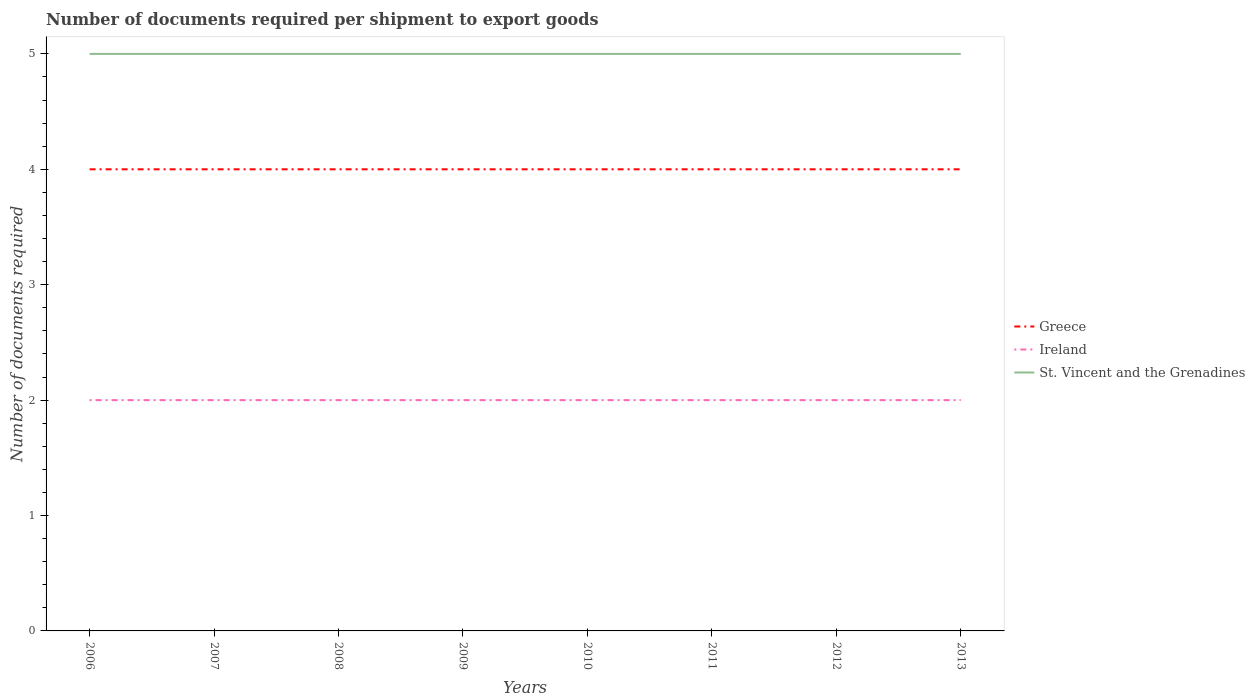Is the number of lines equal to the number of legend labels?
Offer a terse response. Yes. Across all years, what is the maximum number of documents required per shipment to export goods in Ireland?
Offer a terse response. 2. In which year was the number of documents required per shipment to export goods in St. Vincent and the Grenadines maximum?
Keep it short and to the point. 2006. What is the total number of documents required per shipment to export goods in St. Vincent and the Grenadines in the graph?
Ensure brevity in your answer.  0. What is the difference between the highest and the second highest number of documents required per shipment to export goods in Ireland?
Give a very brief answer. 0. Is the number of documents required per shipment to export goods in Greece strictly greater than the number of documents required per shipment to export goods in Ireland over the years?
Give a very brief answer. No. How many lines are there?
Your response must be concise. 3. How many years are there in the graph?
Give a very brief answer. 8. Where does the legend appear in the graph?
Your answer should be very brief. Center right. How many legend labels are there?
Your answer should be very brief. 3. What is the title of the graph?
Give a very brief answer. Number of documents required per shipment to export goods. Does "Iceland" appear as one of the legend labels in the graph?
Provide a succinct answer. No. What is the label or title of the X-axis?
Provide a succinct answer. Years. What is the label or title of the Y-axis?
Keep it short and to the point. Number of documents required. What is the Number of documents required in Greece in 2007?
Your answer should be compact. 4. What is the Number of documents required in St. Vincent and the Grenadines in 2007?
Your response must be concise. 5. What is the Number of documents required in Greece in 2008?
Keep it short and to the point. 4. What is the Number of documents required of Ireland in 2009?
Offer a very short reply. 2. What is the Number of documents required of St. Vincent and the Grenadines in 2009?
Ensure brevity in your answer.  5. What is the Number of documents required in Greece in 2010?
Ensure brevity in your answer.  4. What is the Number of documents required in Ireland in 2010?
Offer a terse response. 2. What is the Number of documents required in St. Vincent and the Grenadines in 2010?
Make the answer very short. 5. What is the Number of documents required of Ireland in 2011?
Make the answer very short. 2. What is the Number of documents required of Greece in 2012?
Provide a short and direct response. 4. What is the Number of documents required of Greece in 2013?
Provide a short and direct response. 4. Across all years, what is the maximum Number of documents required in Greece?
Offer a terse response. 4. Across all years, what is the maximum Number of documents required of Ireland?
Provide a short and direct response. 2. What is the total Number of documents required of Greece in the graph?
Provide a short and direct response. 32. What is the difference between the Number of documents required of Greece in 2006 and that in 2007?
Offer a terse response. 0. What is the difference between the Number of documents required in Ireland in 2006 and that in 2007?
Your response must be concise. 0. What is the difference between the Number of documents required in St. Vincent and the Grenadines in 2006 and that in 2007?
Ensure brevity in your answer.  0. What is the difference between the Number of documents required in Ireland in 2006 and that in 2008?
Your answer should be very brief. 0. What is the difference between the Number of documents required in St. Vincent and the Grenadines in 2006 and that in 2008?
Provide a short and direct response. 0. What is the difference between the Number of documents required in Greece in 2006 and that in 2010?
Your answer should be compact. 0. What is the difference between the Number of documents required of Ireland in 2006 and that in 2010?
Give a very brief answer. 0. What is the difference between the Number of documents required of Ireland in 2006 and that in 2013?
Ensure brevity in your answer.  0. What is the difference between the Number of documents required in St. Vincent and the Grenadines in 2006 and that in 2013?
Make the answer very short. 0. What is the difference between the Number of documents required of Greece in 2007 and that in 2008?
Your answer should be compact. 0. What is the difference between the Number of documents required of St. Vincent and the Grenadines in 2007 and that in 2008?
Provide a short and direct response. 0. What is the difference between the Number of documents required in Greece in 2007 and that in 2009?
Your answer should be compact. 0. What is the difference between the Number of documents required of St. Vincent and the Grenadines in 2007 and that in 2009?
Ensure brevity in your answer.  0. What is the difference between the Number of documents required of Greece in 2007 and that in 2010?
Make the answer very short. 0. What is the difference between the Number of documents required of St. Vincent and the Grenadines in 2007 and that in 2010?
Provide a succinct answer. 0. What is the difference between the Number of documents required in Ireland in 2007 and that in 2011?
Make the answer very short. 0. What is the difference between the Number of documents required in St. Vincent and the Grenadines in 2007 and that in 2012?
Keep it short and to the point. 0. What is the difference between the Number of documents required in Greece in 2007 and that in 2013?
Keep it short and to the point. 0. What is the difference between the Number of documents required of Ireland in 2007 and that in 2013?
Provide a succinct answer. 0. What is the difference between the Number of documents required of Greece in 2008 and that in 2009?
Offer a very short reply. 0. What is the difference between the Number of documents required in Ireland in 2008 and that in 2009?
Provide a short and direct response. 0. What is the difference between the Number of documents required of Greece in 2008 and that in 2010?
Offer a terse response. 0. What is the difference between the Number of documents required of Ireland in 2008 and that in 2010?
Keep it short and to the point. 0. What is the difference between the Number of documents required in Greece in 2008 and that in 2011?
Offer a very short reply. 0. What is the difference between the Number of documents required of Ireland in 2008 and that in 2011?
Give a very brief answer. 0. What is the difference between the Number of documents required of St. Vincent and the Grenadines in 2008 and that in 2011?
Provide a short and direct response. 0. What is the difference between the Number of documents required of Ireland in 2008 and that in 2012?
Your answer should be compact. 0. What is the difference between the Number of documents required in Greece in 2008 and that in 2013?
Your answer should be compact. 0. What is the difference between the Number of documents required of Ireland in 2008 and that in 2013?
Make the answer very short. 0. What is the difference between the Number of documents required of St. Vincent and the Grenadines in 2009 and that in 2010?
Give a very brief answer. 0. What is the difference between the Number of documents required of Ireland in 2009 and that in 2012?
Your answer should be compact. 0. What is the difference between the Number of documents required in St. Vincent and the Grenadines in 2009 and that in 2012?
Provide a short and direct response. 0. What is the difference between the Number of documents required of St. Vincent and the Grenadines in 2009 and that in 2013?
Provide a succinct answer. 0. What is the difference between the Number of documents required of St. Vincent and the Grenadines in 2010 and that in 2011?
Offer a very short reply. 0. What is the difference between the Number of documents required of Greece in 2010 and that in 2012?
Keep it short and to the point. 0. What is the difference between the Number of documents required of Ireland in 2010 and that in 2012?
Make the answer very short. 0. What is the difference between the Number of documents required in Greece in 2010 and that in 2013?
Offer a terse response. 0. What is the difference between the Number of documents required of Ireland in 2010 and that in 2013?
Ensure brevity in your answer.  0. What is the difference between the Number of documents required in St. Vincent and the Grenadines in 2010 and that in 2013?
Make the answer very short. 0. What is the difference between the Number of documents required of Ireland in 2011 and that in 2012?
Your answer should be compact. 0. What is the difference between the Number of documents required of Greece in 2011 and that in 2013?
Provide a short and direct response. 0. What is the difference between the Number of documents required in Ireland in 2012 and that in 2013?
Provide a succinct answer. 0. What is the difference between the Number of documents required in Greece in 2006 and the Number of documents required in Ireland in 2007?
Your answer should be compact. 2. What is the difference between the Number of documents required in Greece in 2006 and the Number of documents required in St. Vincent and the Grenadines in 2007?
Make the answer very short. -1. What is the difference between the Number of documents required of Ireland in 2006 and the Number of documents required of St. Vincent and the Grenadines in 2007?
Give a very brief answer. -3. What is the difference between the Number of documents required in Greece in 2006 and the Number of documents required in St. Vincent and the Grenadines in 2008?
Keep it short and to the point. -1. What is the difference between the Number of documents required of Greece in 2006 and the Number of documents required of Ireland in 2009?
Provide a succinct answer. 2. What is the difference between the Number of documents required in Greece in 2006 and the Number of documents required in St. Vincent and the Grenadines in 2009?
Give a very brief answer. -1. What is the difference between the Number of documents required of Ireland in 2006 and the Number of documents required of St. Vincent and the Grenadines in 2009?
Ensure brevity in your answer.  -3. What is the difference between the Number of documents required in Greece in 2006 and the Number of documents required in Ireland in 2010?
Your answer should be very brief. 2. What is the difference between the Number of documents required of Greece in 2006 and the Number of documents required of St. Vincent and the Grenadines in 2010?
Your response must be concise. -1. What is the difference between the Number of documents required in Greece in 2006 and the Number of documents required in Ireland in 2011?
Make the answer very short. 2. What is the difference between the Number of documents required of Greece in 2006 and the Number of documents required of St. Vincent and the Grenadines in 2011?
Your answer should be very brief. -1. What is the difference between the Number of documents required in Greece in 2006 and the Number of documents required in Ireland in 2012?
Provide a succinct answer. 2. What is the difference between the Number of documents required of Greece in 2006 and the Number of documents required of St. Vincent and the Grenadines in 2012?
Offer a very short reply. -1. What is the difference between the Number of documents required of Ireland in 2006 and the Number of documents required of St. Vincent and the Grenadines in 2012?
Offer a terse response. -3. What is the difference between the Number of documents required in Greece in 2006 and the Number of documents required in Ireland in 2013?
Provide a succinct answer. 2. What is the difference between the Number of documents required of Ireland in 2007 and the Number of documents required of St. Vincent and the Grenadines in 2008?
Your response must be concise. -3. What is the difference between the Number of documents required in Greece in 2007 and the Number of documents required in Ireland in 2010?
Offer a terse response. 2. What is the difference between the Number of documents required of Ireland in 2007 and the Number of documents required of St. Vincent and the Grenadines in 2010?
Your answer should be very brief. -3. What is the difference between the Number of documents required of Greece in 2007 and the Number of documents required of Ireland in 2011?
Keep it short and to the point. 2. What is the difference between the Number of documents required of Greece in 2007 and the Number of documents required of St. Vincent and the Grenadines in 2011?
Provide a short and direct response. -1. What is the difference between the Number of documents required of Greece in 2007 and the Number of documents required of St. Vincent and the Grenadines in 2012?
Make the answer very short. -1. What is the difference between the Number of documents required in Ireland in 2007 and the Number of documents required in St. Vincent and the Grenadines in 2012?
Your answer should be very brief. -3. What is the difference between the Number of documents required in Ireland in 2007 and the Number of documents required in St. Vincent and the Grenadines in 2013?
Your answer should be compact. -3. What is the difference between the Number of documents required of Greece in 2008 and the Number of documents required of Ireland in 2009?
Provide a short and direct response. 2. What is the difference between the Number of documents required in Greece in 2008 and the Number of documents required in St. Vincent and the Grenadines in 2010?
Your answer should be very brief. -1. What is the difference between the Number of documents required of Ireland in 2008 and the Number of documents required of St. Vincent and the Grenadines in 2010?
Your answer should be very brief. -3. What is the difference between the Number of documents required of Greece in 2008 and the Number of documents required of Ireland in 2011?
Your answer should be very brief. 2. What is the difference between the Number of documents required in Ireland in 2008 and the Number of documents required in St. Vincent and the Grenadines in 2011?
Ensure brevity in your answer.  -3. What is the difference between the Number of documents required in Ireland in 2008 and the Number of documents required in St. Vincent and the Grenadines in 2012?
Your answer should be compact. -3. What is the difference between the Number of documents required of Greece in 2008 and the Number of documents required of St. Vincent and the Grenadines in 2013?
Keep it short and to the point. -1. What is the difference between the Number of documents required of Greece in 2009 and the Number of documents required of St. Vincent and the Grenadines in 2010?
Your answer should be very brief. -1. What is the difference between the Number of documents required of Ireland in 2009 and the Number of documents required of St. Vincent and the Grenadines in 2010?
Provide a short and direct response. -3. What is the difference between the Number of documents required in Ireland in 2009 and the Number of documents required in St. Vincent and the Grenadines in 2012?
Ensure brevity in your answer.  -3. What is the difference between the Number of documents required in Greece in 2009 and the Number of documents required in Ireland in 2013?
Your response must be concise. 2. What is the difference between the Number of documents required in Greece in 2009 and the Number of documents required in St. Vincent and the Grenadines in 2013?
Make the answer very short. -1. What is the difference between the Number of documents required in Ireland in 2009 and the Number of documents required in St. Vincent and the Grenadines in 2013?
Offer a terse response. -3. What is the difference between the Number of documents required of Greece in 2010 and the Number of documents required of Ireland in 2011?
Provide a succinct answer. 2. What is the difference between the Number of documents required of Greece in 2010 and the Number of documents required of St. Vincent and the Grenadines in 2011?
Provide a short and direct response. -1. What is the difference between the Number of documents required of Greece in 2010 and the Number of documents required of Ireland in 2012?
Ensure brevity in your answer.  2. What is the difference between the Number of documents required of Greece in 2010 and the Number of documents required of St. Vincent and the Grenadines in 2012?
Provide a succinct answer. -1. What is the difference between the Number of documents required in Ireland in 2010 and the Number of documents required in St. Vincent and the Grenadines in 2012?
Your answer should be very brief. -3. What is the difference between the Number of documents required in Greece in 2010 and the Number of documents required in St. Vincent and the Grenadines in 2013?
Your answer should be compact. -1. What is the difference between the Number of documents required of Ireland in 2010 and the Number of documents required of St. Vincent and the Grenadines in 2013?
Ensure brevity in your answer.  -3. What is the difference between the Number of documents required of Greece in 2011 and the Number of documents required of Ireland in 2012?
Your response must be concise. 2. What is the difference between the Number of documents required of Greece in 2011 and the Number of documents required of St. Vincent and the Grenadines in 2012?
Your answer should be compact. -1. What is the difference between the Number of documents required of Ireland in 2011 and the Number of documents required of St. Vincent and the Grenadines in 2013?
Provide a succinct answer. -3. What is the difference between the Number of documents required of Greece in 2012 and the Number of documents required of St. Vincent and the Grenadines in 2013?
Offer a very short reply. -1. What is the difference between the Number of documents required in Ireland in 2012 and the Number of documents required in St. Vincent and the Grenadines in 2013?
Make the answer very short. -3. What is the average Number of documents required of Ireland per year?
Your answer should be very brief. 2. What is the average Number of documents required in St. Vincent and the Grenadines per year?
Your answer should be very brief. 5. In the year 2006, what is the difference between the Number of documents required of Greece and Number of documents required of Ireland?
Your answer should be very brief. 2. In the year 2006, what is the difference between the Number of documents required of Greece and Number of documents required of St. Vincent and the Grenadines?
Give a very brief answer. -1. In the year 2008, what is the difference between the Number of documents required in Greece and Number of documents required in St. Vincent and the Grenadines?
Your answer should be very brief. -1. In the year 2009, what is the difference between the Number of documents required in Ireland and Number of documents required in St. Vincent and the Grenadines?
Make the answer very short. -3. In the year 2010, what is the difference between the Number of documents required of Greece and Number of documents required of Ireland?
Keep it short and to the point. 2. In the year 2010, what is the difference between the Number of documents required in Ireland and Number of documents required in St. Vincent and the Grenadines?
Provide a succinct answer. -3. In the year 2011, what is the difference between the Number of documents required in Greece and Number of documents required in Ireland?
Provide a short and direct response. 2. In the year 2012, what is the difference between the Number of documents required of Ireland and Number of documents required of St. Vincent and the Grenadines?
Offer a terse response. -3. In the year 2013, what is the difference between the Number of documents required in Greece and Number of documents required in Ireland?
Your answer should be very brief. 2. In the year 2013, what is the difference between the Number of documents required in Ireland and Number of documents required in St. Vincent and the Grenadines?
Make the answer very short. -3. What is the ratio of the Number of documents required in Ireland in 2006 to that in 2007?
Provide a succinct answer. 1. What is the ratio of the Number of documents required of St. Vincent and the Grenadines in 2006 to that in 2007?
Make the answer very short. 1. What is the ratio of the Number of documents required in Greece in 2006 to that in 2009?
Keep it short and to the point. 1. What is the ratio of the Number of documents required in Ireland in 2006 to that in 2009?
Your answer should be compact. 1. What is the ratio of the Number of documents required of St. Vincent and the Grenadines in 2006 to that in 2009?
Your answer should be compact. 1. What is the ratio of the Number of documents required in Greece in 2006 to that in 2010?
Your answer should be very brief. 1. What is the ratio of the Number of documents required of St. Vincent and the Grenadines in 2006 to that in 2010?
Offer a very short reply. 1. What is the ratio of the Number of documents required of Ireland in 2006 to that in 2011?
Offer a terse response. 1. What is the ratio of the Number of documents required in Greece in 2006 to that in 2012?
Provide a short and direct response. 1. What is the ratio of the Number of documents required in St. Vincent and the Grenadines in 2006 to that in 2012?
Offer a terse response. 1. What is the ratio of the Number of documents required of Greece in 2007 to that in 2008?
Provide a succinct answer. 1. What is the ratio of the Number of documents required of St. Vincent and the Grenadines in 2007 to that in 2008?
Keep it short and to the point. 1. What is the ratio of the Number of documents required of Greece in 2007 to that in 2009?
Your response must be concise. 1. What is the ratio of the Number of documents required of Greece in 2007 to that in 2010?
Give a very brief answer. 1. What is the ratio of the Number of documents required of St. Vincent and the Grenadines in 2007 to that in 2010?
Provide a succinct answer. 1. What is the ratio of the Number of documents required of Greece in 2007 to that in 2011?
Your response must be concise. 1. What is the ratio of the Number of documents required of Ireland in 2007 to that in 2011?
Provide a short and direct response. 1. What is the ratio of the Number of documents required of St. Vincent and the Grenadines in 2007 to that in 2011?
Provide a succinct answer. 1. What is the ratio of the Number of documents required in Greece in 2007 to that in 2013?
Give a very brief answer. 1. What is the ratio of the Number of documents required of Ireland in 2007 to that in 2013?
Offer a terse response. 1. What is the ratio of the Number of documents required in St. Vincent and the Grenadines in 2007 to that in 2013?
Make the answer very short. 1. What is the ratio of the Number of documents required in Ireland in 2008 to that in 2009?
Your response must be concise. 1. What is the ratio of the Number of documents required in St. Vincent and the Grenadines in 2008 to that in 2010?
Offer a terse response. 1. What is the ratio of the Number of documents required of Ireland in 2008 to that in 2011?
Offer a very short reply. 1. What is the ratio of the Number of documents required of Greece in 2008 to that in 2012?
Your response must be concise. 1. What is the ratio of the Number of documents required in St. Vincent and the Grenadines in 2008 to that in 2013?
Offer a terse response. 1. What is the ratio of the Number of documents required of Greece in 2009 to that in 2010?
Give a very brief answer. 1. What is the ratio of the Number of documents required in Greece in 2009 to that in 2011?
Keep it short and to the point. 1. What is the ratio of the Number of documents required in St. Vincent and the Grenadines in 2009 to that in 2011?
Offer a terse response. 1. What is the ratio of the Number of documents required in Ireland in 2009 to that in 2012?
Your answer should be compact. 1. What is the ratio of the Number of documents required in St. Vincent and the Grenadines in 2010 to that in 2011?
Offer a very short reply. 1. What is the ratio of the Number of documents required of Greece in 2010 to that in 2012?
Your answer should be compact. 1. What is the ratio of the Number of documents required of Greece in 2010 to that in 2013?
Your answer should be very brief. 1. What is the ratio of the Number of documents required in Ireland in 2010 to that in 2013?
Give a very brief answer. 1. What is the ratio of the Number of documents required in Greece in 2011 to that in 2013?
Your answer should be compact. 1. What is the ratio of the Number of documents required of Ireland in 2011 to that in 2013?
Your response must be concise. 1. What is the ratio of the Number of documents required of St. Vincent and the Grenadines in 2011 to that in 2013?
Your answer should be very brief. 1. What is the ratio of the Number of documents required of Greece in 2012 to that in 2013?
Offer a very short reply. 1. What is the ratio of the Number of documents required in Ireland in 2012 to that in 2013?
Provide a short and direct response. 1. What is the ratio of the Number of documents required of St. Vincent and the Grenadines in 2012 to that in 2013?
Your response must be concise. 1. What is the difference between the highest and the second highest Number of documents required of St. Vincent and the Grenadines?
Give a very brief answer. 0. What is the difference between the highest and the lowest Number of documents required in Ireland?
Give a very brief answer. 0. What is the difference between the highest and the lowest Number of documents required of St. Vincent and the Grenadines?
Offer a very short reply. 0. 